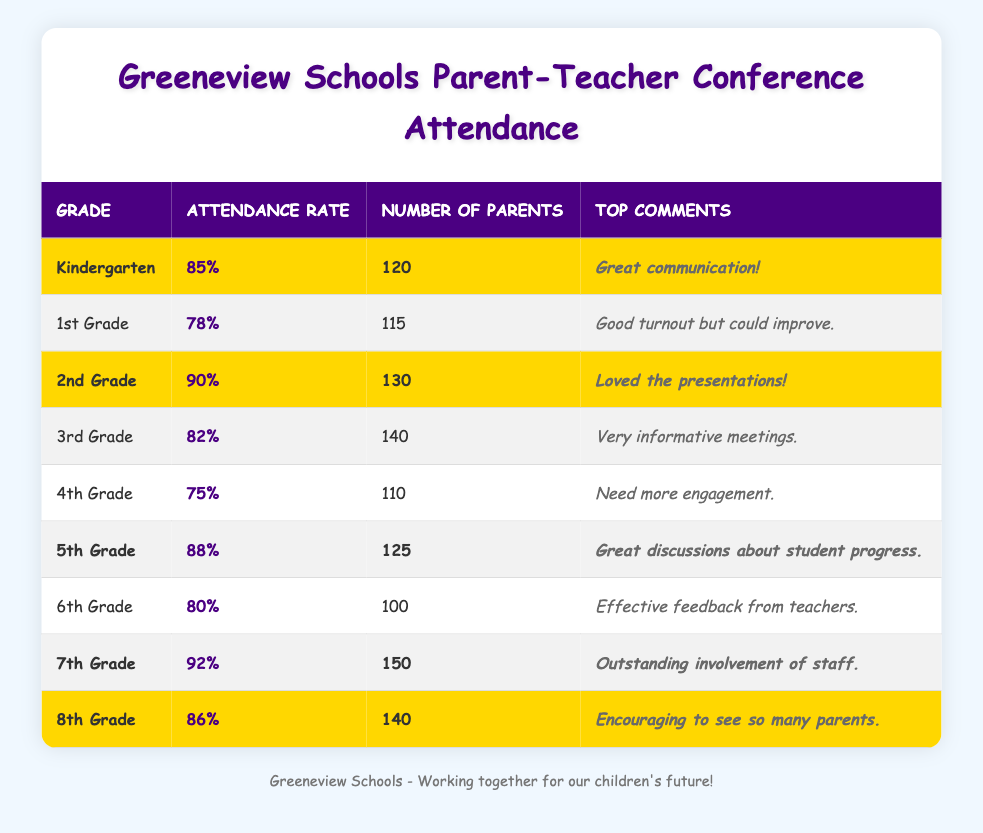What was the attendance rate for 2nd Grade? The attendance rate for 2nd Grade is directly stated in the table as 90%.
Answer: 90% How many parents attended the Parent-Teacher Conference for 5th Grade? The number of parents for 5th Grade is indicated in the table as 125.
Answer: 125 Which grade had the highest attendance rate? By comparing the attendance rates from each row, the highest is 92% for 7th Grade.
Answer: 7th Grade Was the attendance rate for Kindergarten higher than that for 4th Grade? The attendance rate for Kindergarten is 85%, while for 4th Grade it is 75%, confirming that Kindergarten had higher attendance.
Answer: Yes How many more parents attended 8th Grade compared to 4th Grade? 8th Grade had 140 parents and 4th Grade had 110 parents. The difference is 140 - 110 = 30.
Answer: 30 parents What is the average attendance rate for Kindergarten, 2nd Grade, and 5th Grade? The attendance rates for these grades are 85%, 90%, and 88%. The average is (85 + 90 + 88) / 3 = 87.67%.
Answer: 87.67% Is the statement "More than 80% of parents attended conferences in 6th Grade" true or false? The attendance rate for 6th Grade is 80%, which is not more than 80%, therefore the statement is false.
Answer: False Which grades had attendance rates above 85%? Looking through the attendance rates, the grades that had rates above 85% are 2nd Grade (90%), 5th Grade (88%), 7th Grade (92%), and 8th Grade (86%).
Answer: 2nd, 5th, 7th, and 8th Grades What percentage of parents attended conferences in 1st Grade? The attendance rate for 1st Grade is explicitly listed in the table as 78%.
Answer: 78% How many total parents attended the conferences for 6th and 7th Grades combined? The number of parents for 6th Grade is 100 and for 7th Grade is 150, so the total is 100 + 150 = 250.
Answer: 250 parents 